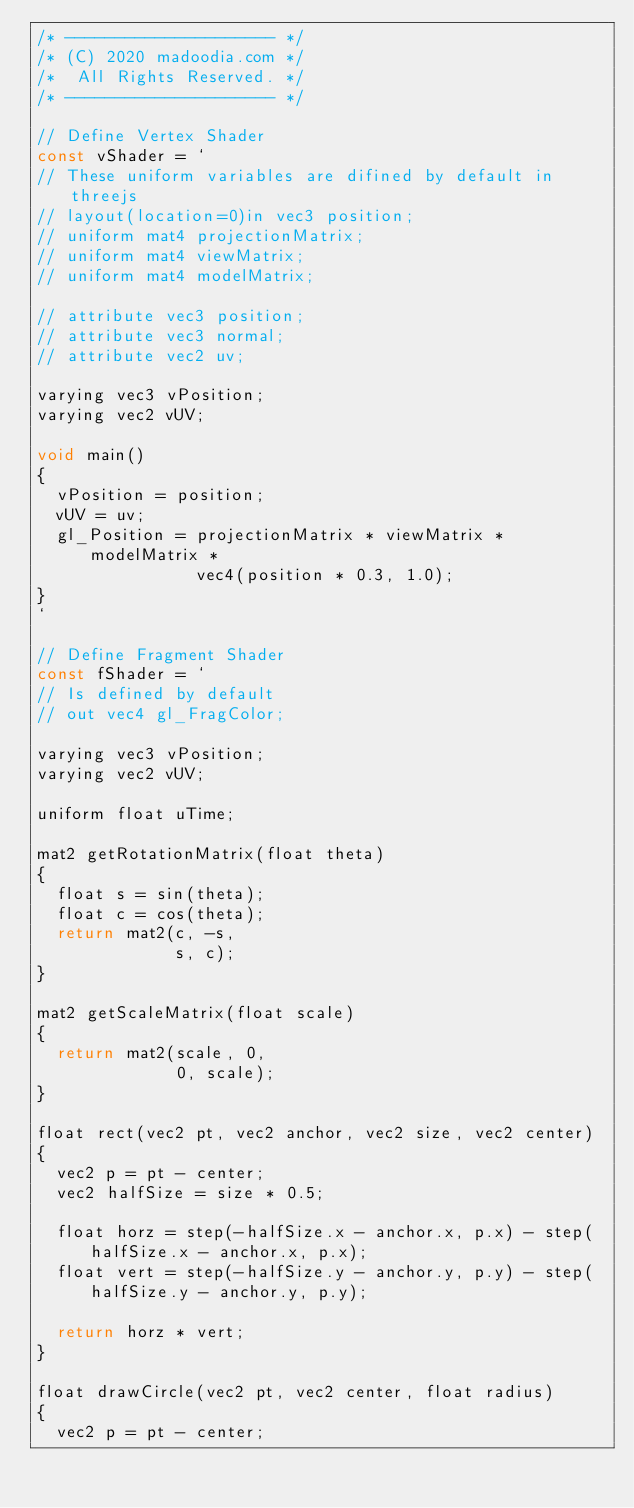<code> <loc_0><loc_0><loc_500><loc_500><_JavaScript_>/* --------------------- */
/* (C) 2020 madoodia.com */
/*  All Rights Reserved. */
/* --------------------- */

// Define Vertex Shader
const vShader = `
// These uniform variables are difined by default in threejs
// layout(location=0)in vec3 position;
// uniform mat4 projectionMatrix;
// uniform mat4 viewMatrix;
// uniform mat4 modelMatrix;

// attribute vec3 position;
// attribute vec3 normal;
// attribute vec2 uv;

varying vec3 vPosition;
varying vec2 vUV;

void main()
{
  vPosition = position;
  vUV = uv;
  gl_Position = projectionMatrix * viewMatrix * modelMatrix * 
                vec4(position * 0.3, 1.0);
}
`

// Define Fragment Shader
const fShader = `
// Is defined by default
// out vec4 gl_FragColor;

varying vec3 vPosition;
varying vec2 vUV;

uniform float uTime;

mat2 getRotationMatrix(float theta)
{
  float s = sin(theta);
  float c = cos(theta);
  return mat2(c, -s, 
              s, c);
}

mat2 getScaleMatrix(float scale)
{
  return mat2(scale, 0, 
              0, scale);
}

float rect(vec2 pt, vec2 anchor, vec2 size, vec2 center)
{
  vec2 p = pt - center;
  vec2 halfSize = size * 0.5;

  float horz = step(-halfSize.x - anchor.x, p.x) - step(halfSize.x - anchor.x, p.x);
  float vert = step(-halfSize.y - anchor.y, p.y) - step(halfSize.y - anchor.y, p.y);

  return horz * vert;
}

float drawCircle(vec2 pt, vec2 center, float radius)
{
  vec2 p = pt - center;</code> 